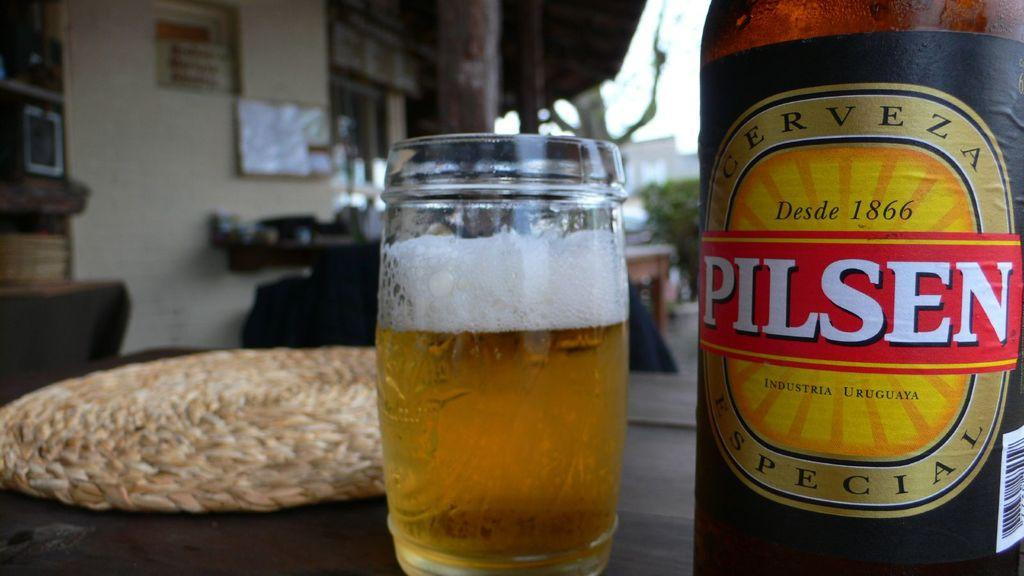What is the main object on the table in the image? There is a wine bottle in the image. What is placed next to the wine bottle? There is a glass in the image. What is on the table that provides a cushioned surface? There is a mat on the table in the image. What can be seen in the background of the image? There are boards to the building, pillars, trees, and the sky visible in the background of the image. What type of vest is the father wearing in the image? There is no father or vest present in the image. How does love manifest itself in the image? The image does not depict any emotions or feelings, including love. 